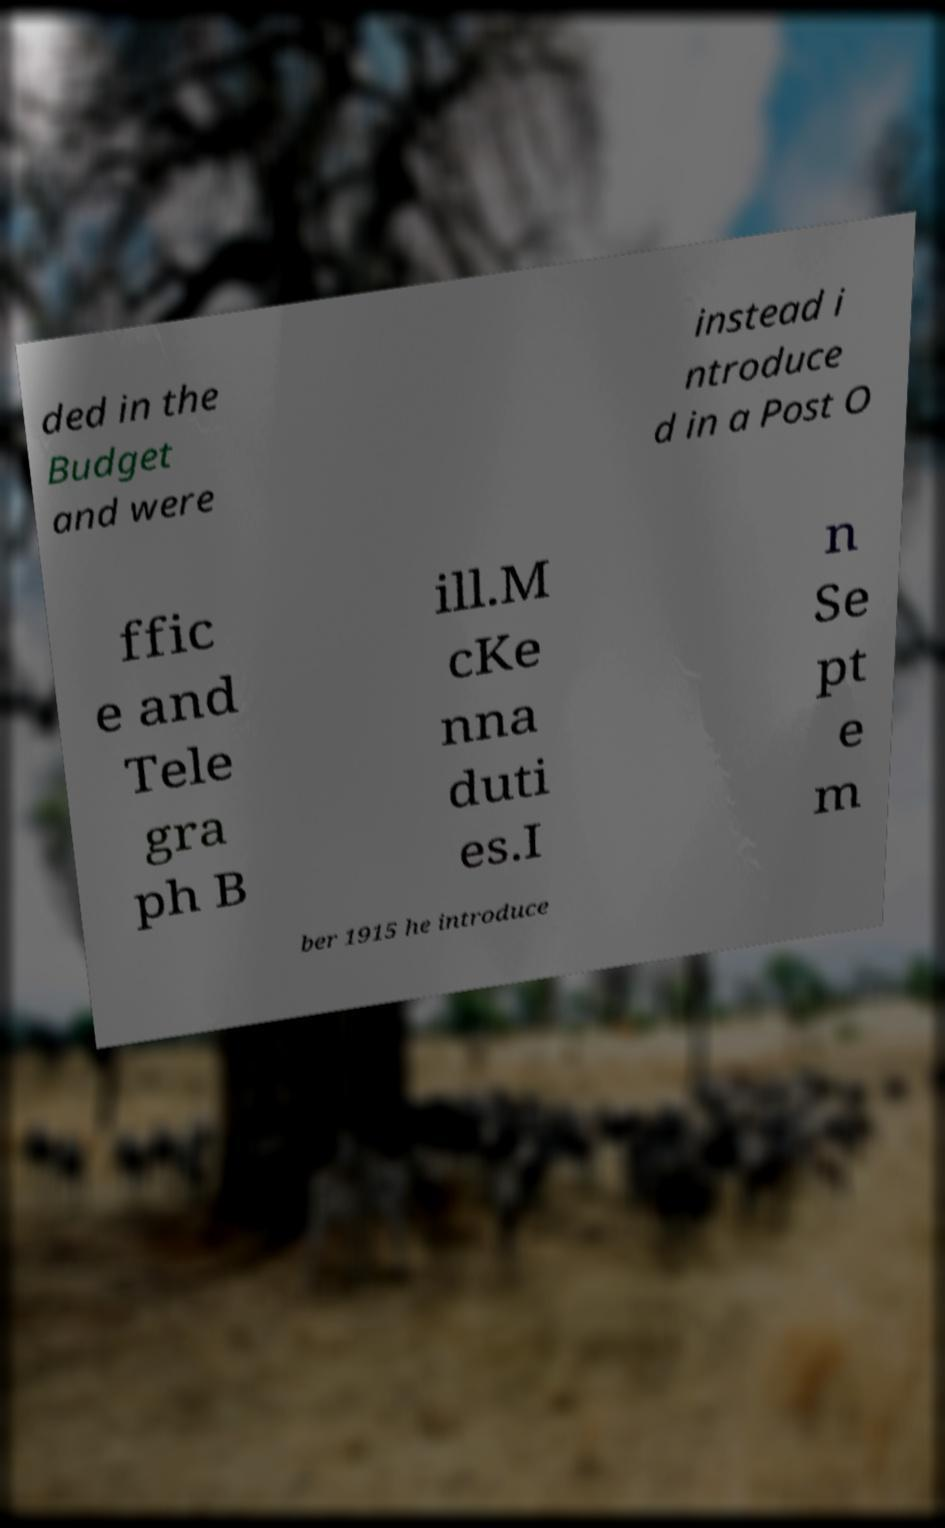Please identify and transcribe the text found in this image. ded in the Budget and were instead i ntroduce d in a Post O ffic e and Tele gra ph B ill.M cKe nna duti es.I n Se pt e m ber 1915 he introduce 